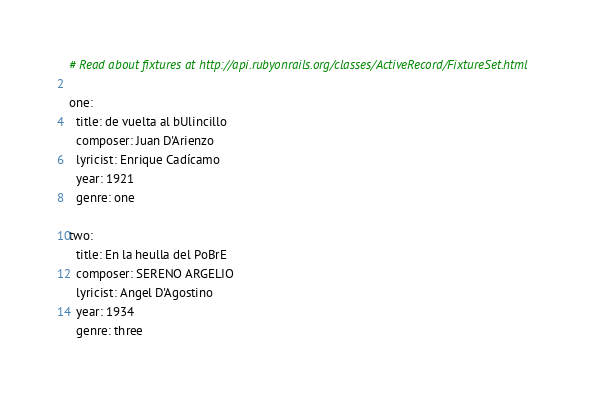Convert code to text. <code><loc_0><loc_0><loc_500><loc_500><_YAML_># Read about fixtures at http://api.rubyonrails.org/classes/ActiveRecord/FixtureSet.html

one:
  title: de vuelta al bUlincillo
  composer: Juan D'Arienzo
  lyricist: Enrique Cadícamo
  year: 1921
  genre: one

two:
  title: En la heulla del PoBrE
  composer: SERENO ARGELIO
  lyricist: Angel D'Agostino
  year: 1934
  genre: three
</code> 